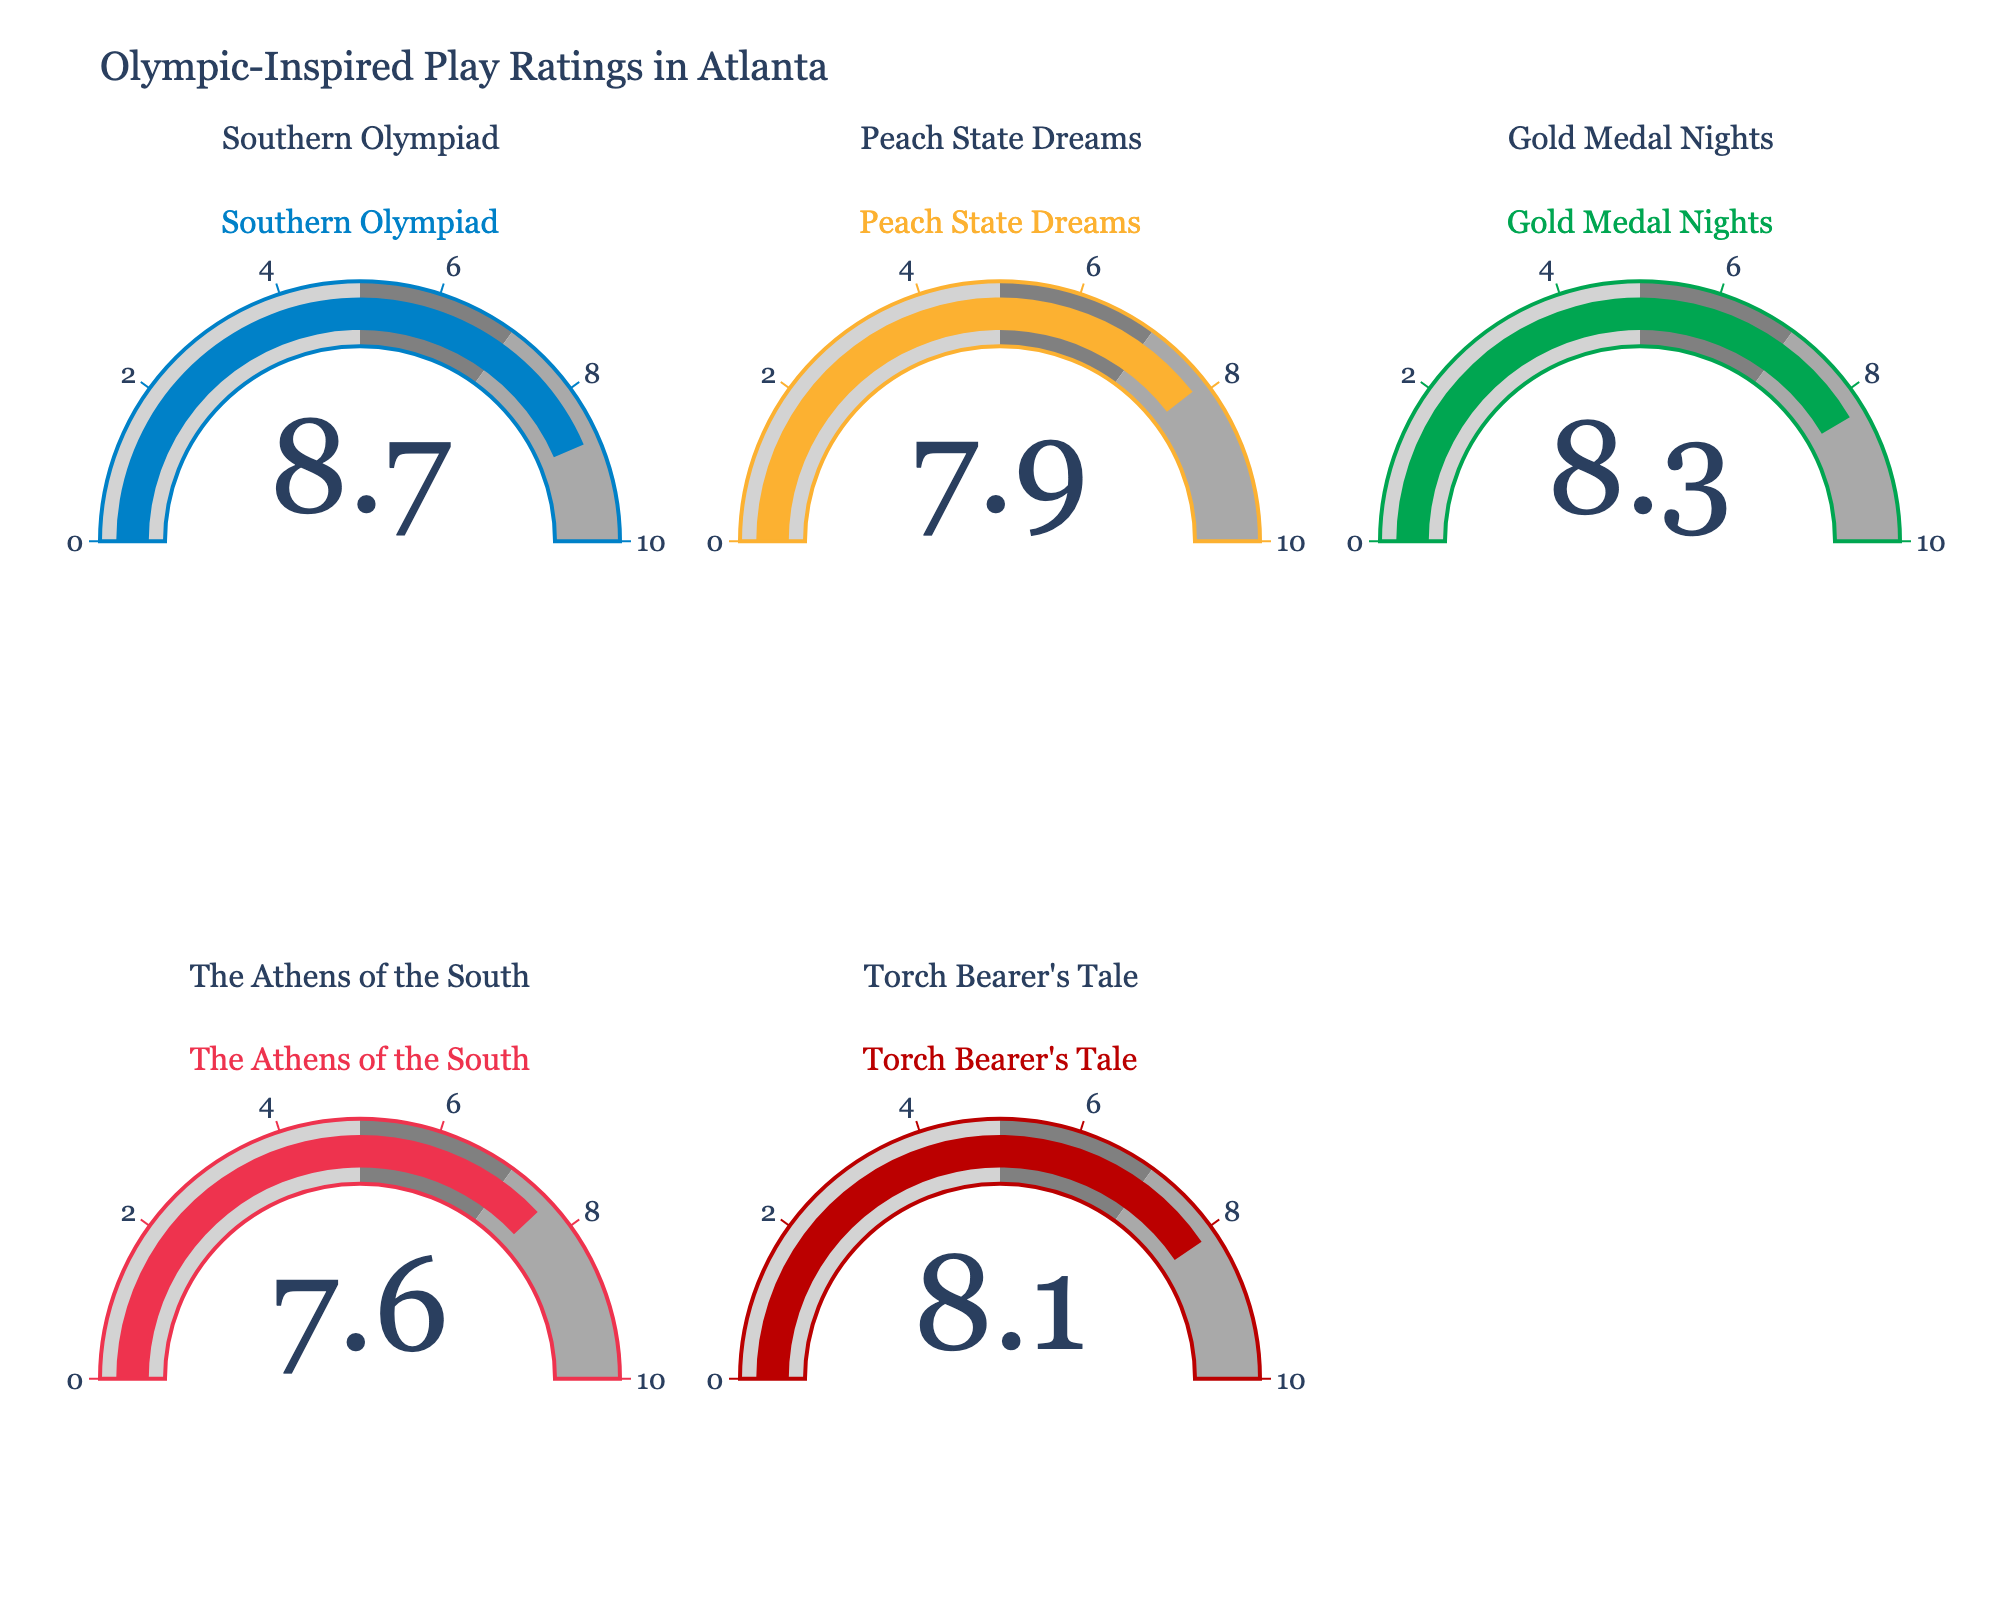What's the title of the figure? The title of the figure can be found at the top of the chart. It states "Olympic-Inspired Play Ratings in Atlanta".
Answer: Olympic-Inspired Play Ratings in Atlanta How many plays are displayed in the figure? By counting the number of gauges (each representing a play) in the chart, we can determine there are five plays displayed.
Answer: 5 What is the average audience rating for "Southern Olympiad"? The value displayed on the gauge titled "Southern Olympiad" shows an average rating of 8.7.
Answer: 8.7 Which play has the lowest average rating? By comparing the values on all the gauges, "The Athens of the South" has the lowest rating of 7.6.
Answer: The Athens of the South What's the difference in average rating between "Southern Olympiad" and "The Athens of the South"? Subtract the average rating of "The Athens of the South" (7.6) from that of "Southern Olympiad" (8.7). 8.7 - 7.6 = 1.1.
Answer: 1.1 Which play has an average rating closest to 8? “Torch Bearer's Tale” has the closest rating to 8, with an average rating of 8.1.
Answer: Torch Bearer's Tale What is the total sum of the average ratings of all the plays? Sum the ratings of all five plays: 8.7 (Southern Olympiad) + 7.9 (Peach State Dreams) + 8.3 (Gold Medal Nights) + 7.6 (The Athens of the South) + 8.1 (Torch Bearer's Tale). 8.7 + 7.9 + 8.3 + 7.6 + 8.1 = 40.6.
Answer: 40.6 How many plays have an average rating above 8? By looking at the gauges, "Southern Olympiad" (8.7), "Gold Medal Nights" (8.3), and "Torch Bearer's Tale" (8.1) are the plays with average ratings above 8.
Answer: 3 Which play has an average rating between 7 and 8? "Peach State Dreams" (7.9) and "The Athens of the South” (7.6) have average ratings between 7 and 8.
Answer: Peach State Dreams and The Athens of the South 